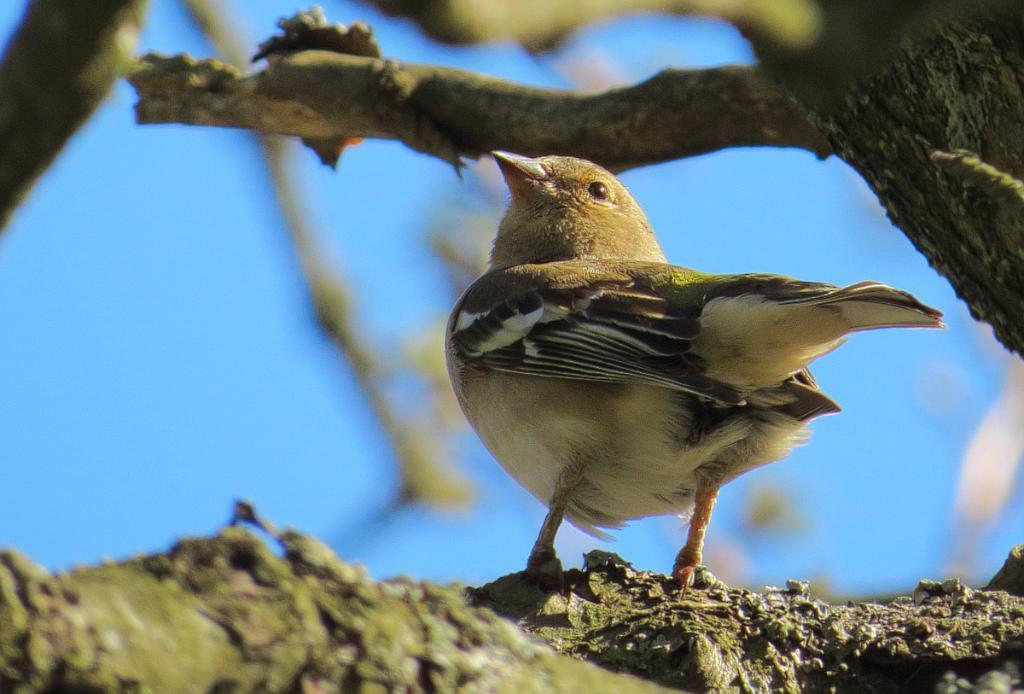Can you describe this image briefly? In this picture I can see a bird on the tree bark and I can see blue sky. 